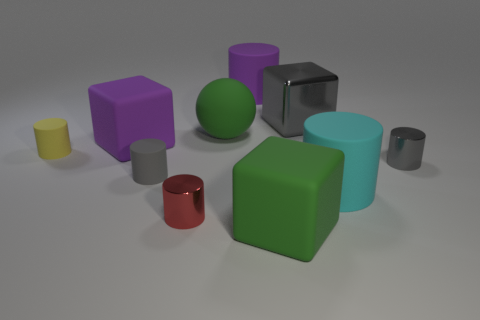How many other things are made of the same material as the yellow object?
Offer a very short reply. 6. What size is the gray metal thing that is in front of the big green rubber ball?
Provide a succinct answer. Small. There is a small shiny thing that is on the left side of the thing behind the metal block; what is its shape?
Ensure brevity in your answer.  Cylinder. There is a tiny cylinder to the left of the large purple thing that is in front of the purple cylinder; what number of blocks are behind it?
Offer a terse response. 2. Is the number of tiny gray metal cylinders that are on the left side of the gray shiny block less than the number of large things?
Offer a very short reply. Yes. Is there any other thing that is the same shape as the large cyan matte thing?
Give a very brief answer. Yes. What shape is the metallic thing that is to the left of the big green matte cube?
Your answer should be compact. Cylinder. There is a green object that is left of the purple thing behind the large purple cube that is behind the large green rubber cube; what is its shape?
Provide a short and direct response. Sphere. How many things are large green rubber balls or small shiny balls?
Your answer should be very brief. 1. There is a green thing in front of the yellow cylinder; is its shape the same as the metallic object that is in front of the gray matte thing?
Ensure brevity in your answer.  No. 